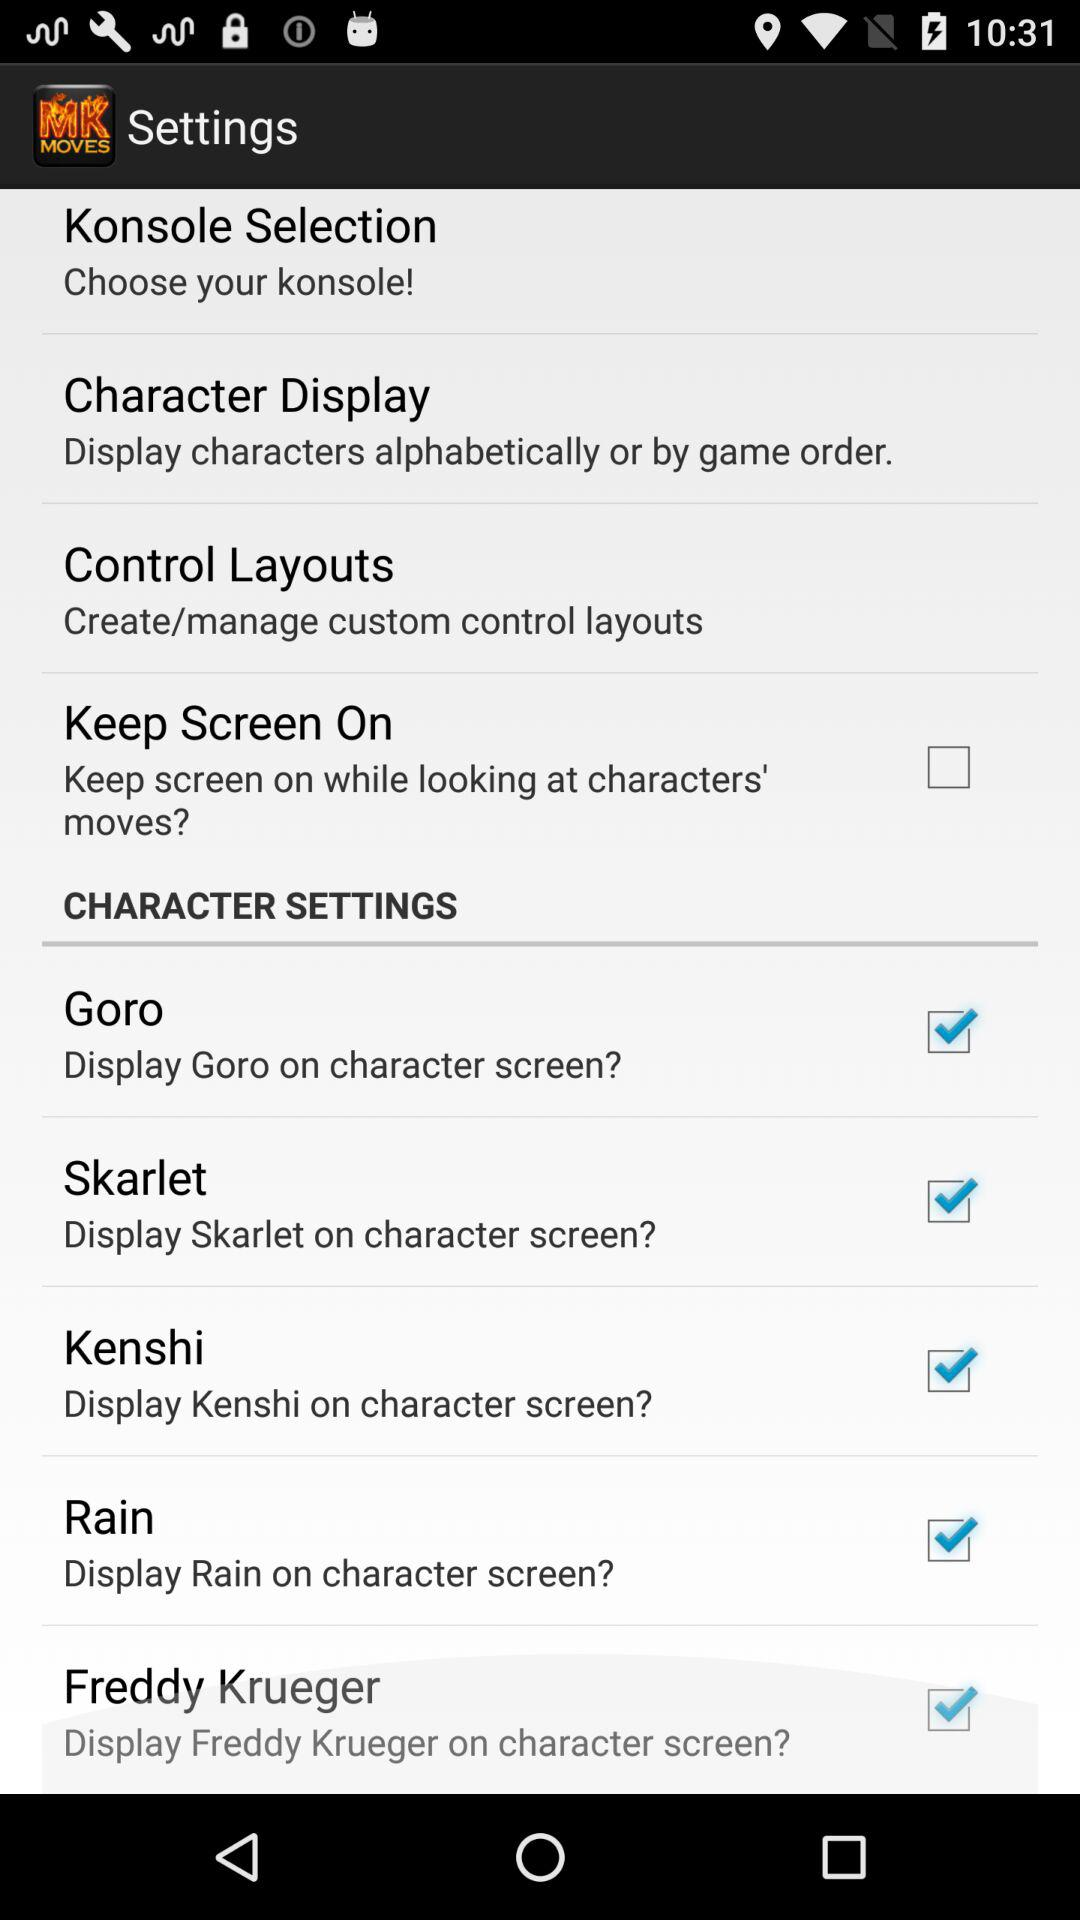What is the application name? The application name is "Moves for Mortal Kombat". 